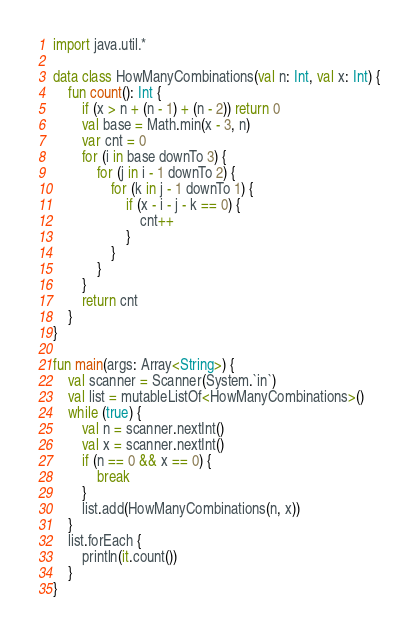<code> <loc_0><loc_0><loc_500><loc_500><_Kotlin_>import java.util.*

data class HowManyCombinations(val n: Int, val x: Int) {
    fun count(): Int {
        if (x > n + (n - 1) + (n - 2)) return 0
        val base = Math.min(x - 3, n)
        var cnt = 0
        for (i in base downTo 3) {
            for (j in i - 1 downTo 2) {
                for (k in j - 1 downTo 1) {
                    if (x - i - j - k == 0) {
                        cnt++
                    }
                }
            }
        }
        return cnt
    }
}

fun main(args: Array<String>) {
    val scanner = Scanner(System.`in`)
    val list = mutableListOf<HowManyCombinations>()
    while (true) {
        val n = scanner.nextInt()
        val x = scanner.nextInt()
        if (n == 0 && x == 0) {
            break
        }
        list.add(HowManyCombinations(n, x))
    }
    list.forEach {
        println(it.count())
    }
}
</code> 